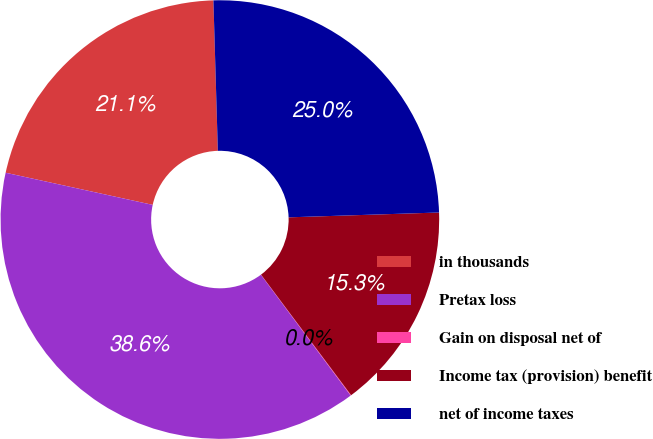<chart> <loc_0><loc_0><loc_500><loc_500><pie_chart><fcel>in thousands<fcel>Pretax loss<fcel>Gain on disposal net of<fcel>Income tax (provision) benefit<fcel>net of income taxes<nl><fcel>21.11%<fcel>38.6%<fcel>0.04%<fcel>15.3%<fcel>24.96%<nl></chart> 